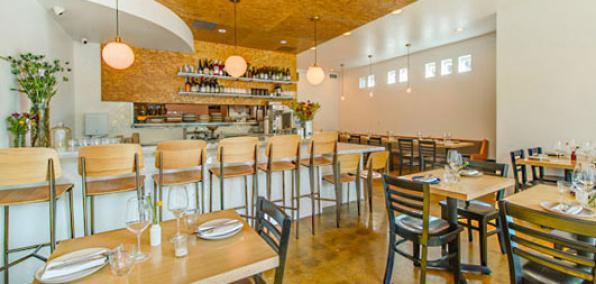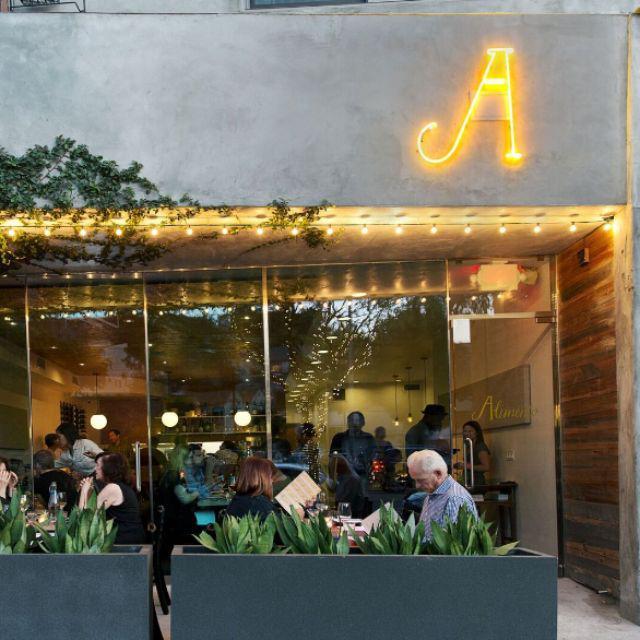The first image is the image on the left, the second image is the image on the right. Analyze the images presented: Is the assertion "One image shows both bar- and table-seating inside a restaurant, while a second image shows outdoor table seating." valid? Answer yes or no. Yes. The first image is the image on the left, the second image is the image on the right. Analyze the images presented: Is the assertion "An exterior features a row of dark gray planters containing spiky green plants, in front of tables where customers are sitting, which are in front of a recessed window with a string of lights over it." valid? Answer yes or no. Yes. 